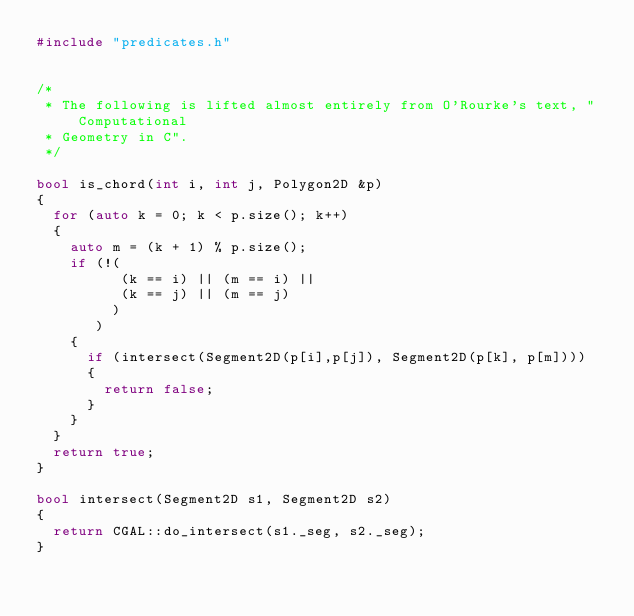Convert code to text. <code><loc_0><loc_0><loc_500><loc_500><_C++_>#include "predicates.h"


/* 
 * The following is lifted almost entirely from O'Rourke's text, "Computational
 * Geometry in C".
 */

bool is_chord(int i, int j, Polygon2D &p) 
{
  for (auto k = 0; k < p.size(); k++)
  {
    auto m = (k + 1) % p.size();
    if (!(
          (k == i) || (m == i) ||
          (k == j) || (m == j)
         )
       )
    {
      if (intersect(Segment2D(p[i],p[j]), Segment2D(p[k], p[m])))
      {
        return false;
      }
    }
  }
  return true;
}

bool intersect(Segment2D s1, Segment2D s2) 
{
  return CGAL::do_intersect(s1._seg, s2._seg);
}
</code> 